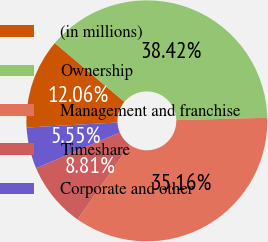<chart> <loc_0><loc_0><loc_500><loc_500><pie_chart><fcel>(in millions)<fcel>Ownership<fcel>Management and franchise<fcel>Timeshare<fcel>Corporate and other<nl><fcel>12.06%<fcel>38.42%<fcel>35.16%<fcel>8.81%<fcel>5.55%<nl></chart> 